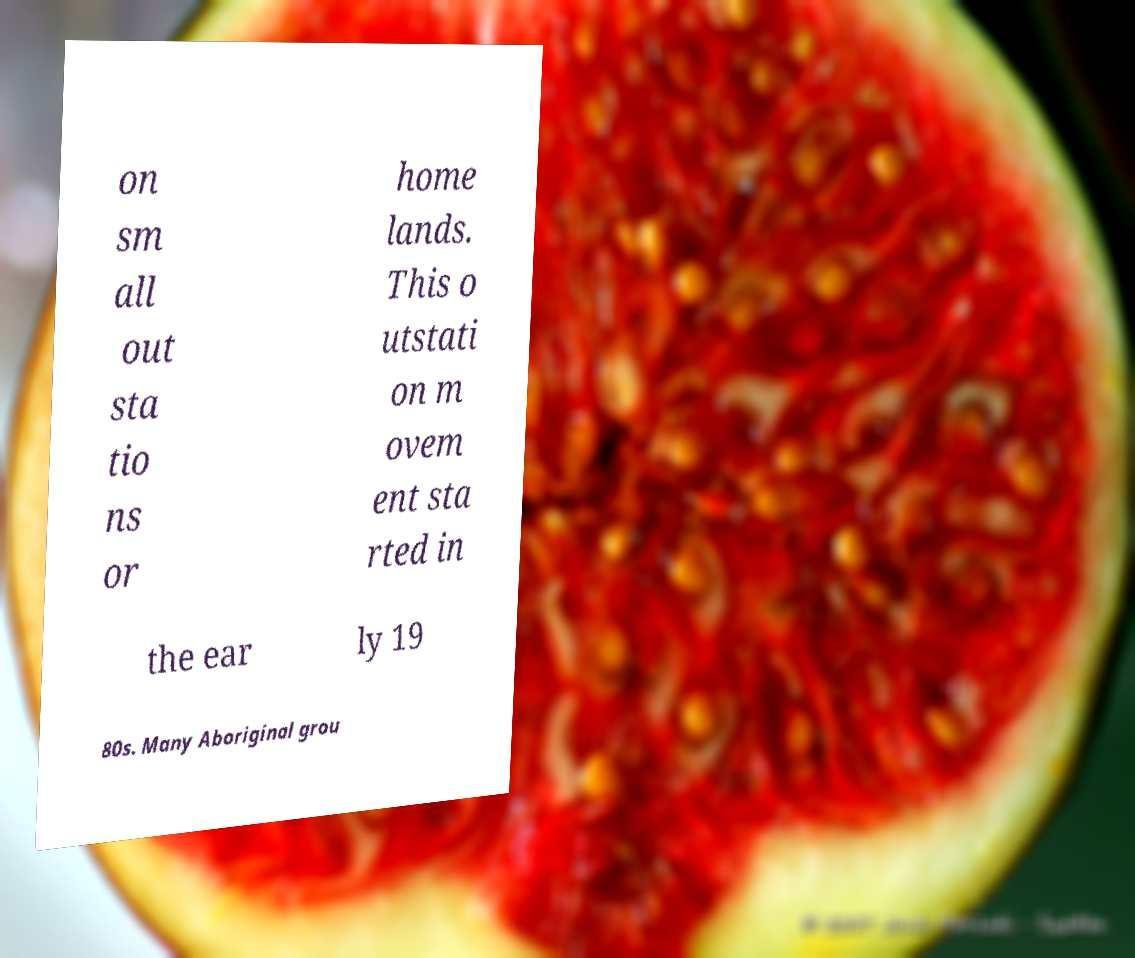Could you extract and type out the text from this image? on sm all out sta tio ns or home lands. This o utstati on m ovem ent sta rted in the ear ly 19 80s. Many Aboriginal grou 